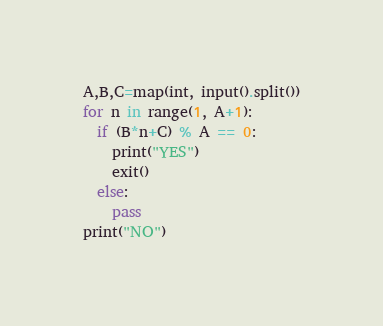<code> <loc_0><loc_0><loc_500><loc_500><_Python_>A,B,C=map(int, input().split())
for n in range(1, A+1):
  if (B*n+C) % A == 0:
    print("YES")
    exit()
  else:
    pass
print("NO")</code> 